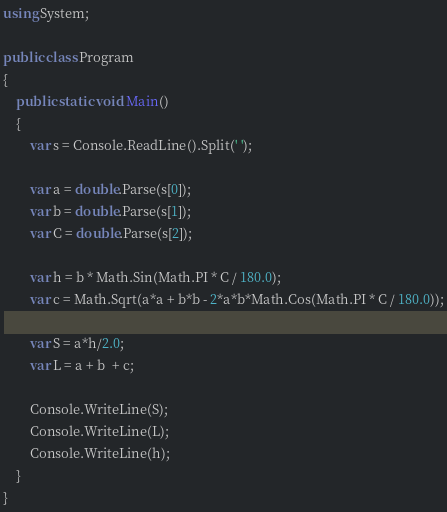Convert code to text. <code><loc_0><loc_0><loc_500><loc_500><_C#_>using System;
					
public class Program
{
	public static void Main()
	{
		var s = Console.ReadLine().Split(' ');
		
		var a = double.Parse(s[0]);
		var b = double.Parse(s[1]);
		var C = double.Parse(s[2]);
		
		var h = b * Math.Sin(Math.PI * C / 180.0);
		var c = Math.Sqrt(a*a + b*b - 2*a*b*Math.Cos(Math.PI * C / 180.0));
		
		var S = a*h/2.0;
		var L = a + b  + c;
		
		Console.WriteLine(S);
		Console.WriteLine(L);
		Console.WriteLine(h);
	}
}</code> 